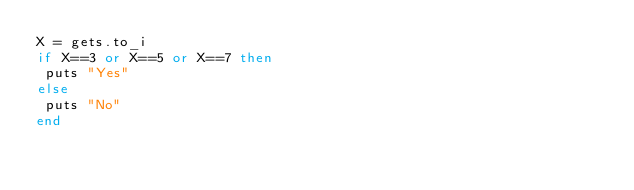Convert code to text. <code><loc_0><loc_0><loc_500><loc_500><_Ruby_>X = gets.to_i
if X==3 or X==5 or X==7 then
 puts "Yes"
else
 puts "No"
end</code> 